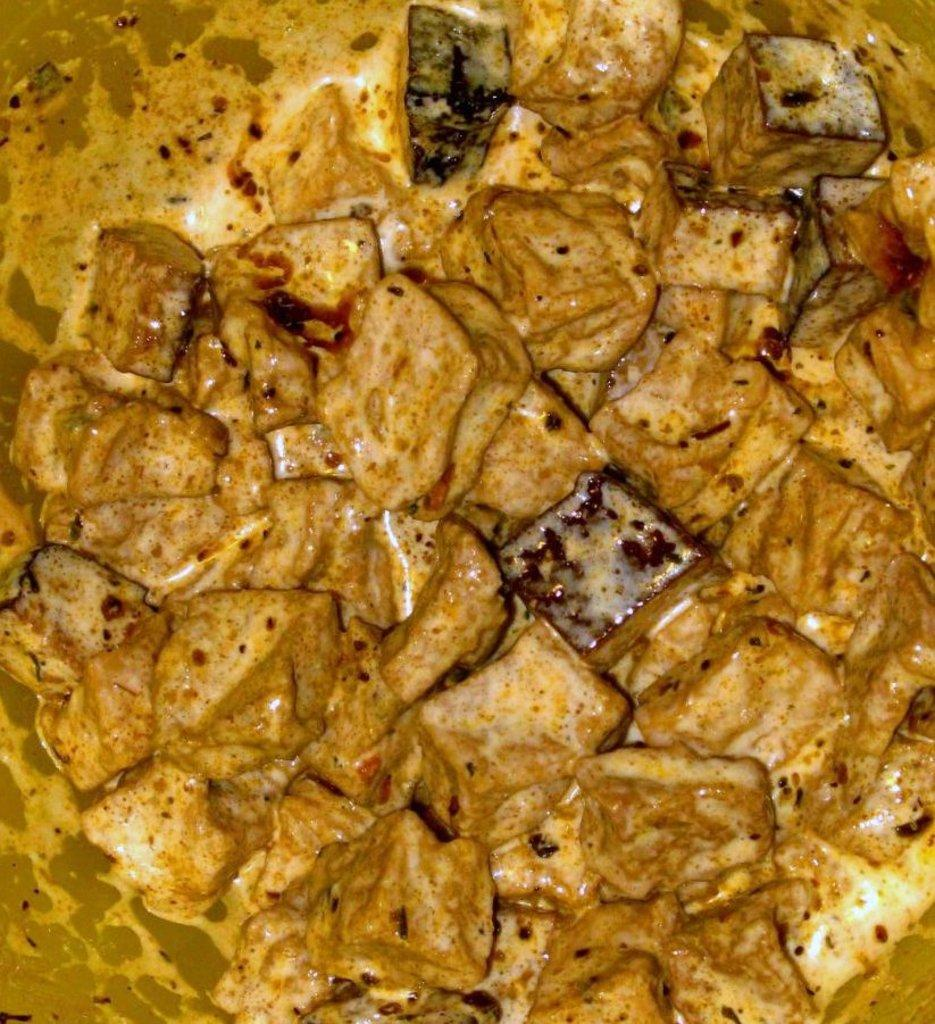What type of food item can be seen in the image? There are pieces of a food item in the image. How are the food items arranged in the image? The food items are arranged in a soup. What color is the feather floating in the soup in the image? There is no feather present in the image; it only shows pieces of a food item arranged in a soup. 